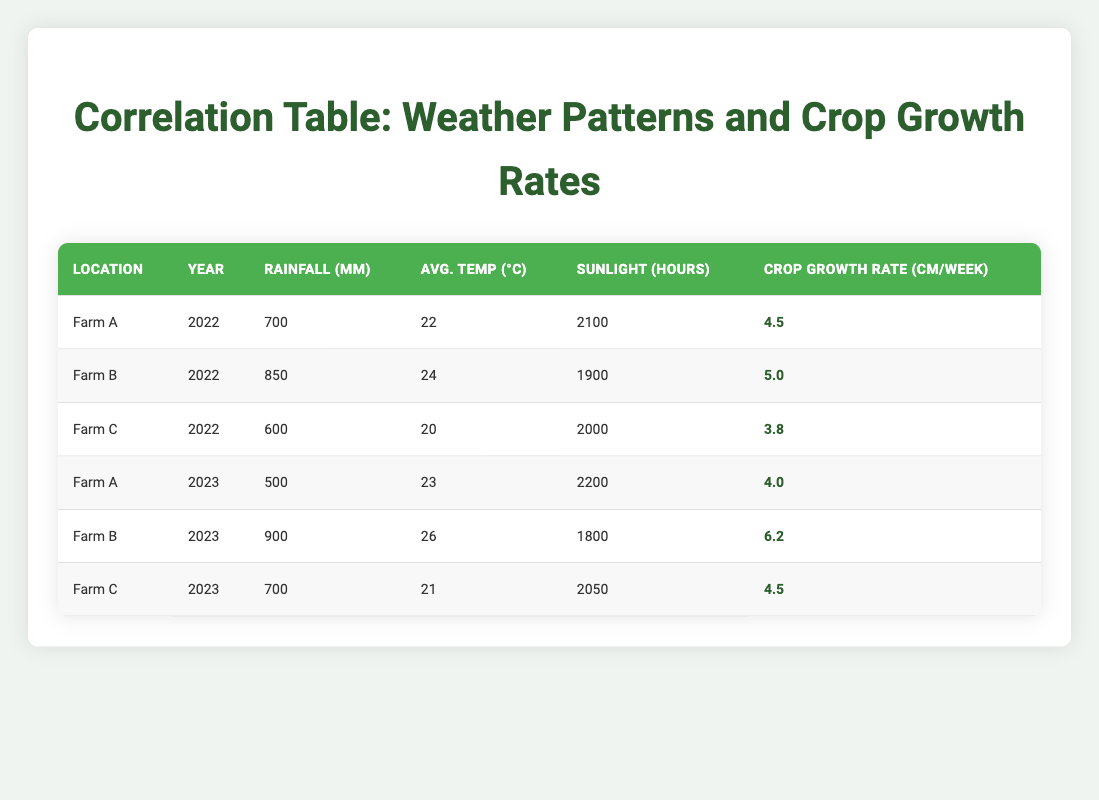What is the average rainfall across all farms in the year 2022? For Farm A, the rainfall is 700 mm, for Farm B it is 850 mm, and for Farm C it is 600 mm. To find the average, sum these values: 700 + 850 + 600 = 2150 mm. Then divide by the number of farms, which is 3: 2150 / 3 = 716.67 mm.
Answer: 716.67 mm Which farm had the highest crop growth rate in 2023? In 2023, Farm A has a crop growth rate of 4.0 cm/week, Farm B has 6.2 cm/week, and Farm C has 4.5 cm/week. By comparing these values, Farm B has the highest crop growth rate of 6.2 cm/week.
Answer: Farm B Did Farm C have a higher average temperature in 2022 than in 2023? Farm C's average temperature in 2022 is 20°C, while in 2023 it is 21°C. Therefore, Farm C's average temperature in 2023 is indeed higher than in 2022.
Answer: Yes What was the total amount of sunlight hours for all farms in 2022? The sunlight hours for Farm A in 2022 are 2100 hours, for Farm B it is 1900 hours, and for Farm C it is 2000 hours. Adding these values together: 2100 + 1900 + 2000 = 6000 hours in total.
Answer: 6000 hours Is there a correlation between rainfall and crop growth rate across the data provided? In the data for 2022, higher rainfall (850 mm for Farm B) corresponds to the highest crop growth rate (5.0 cm/week). However, in 2023, lower rainfall (500 mm for Farm A) shows a crop growth rate of 4.0 cm/week. This indicates inconsistent correlation, but generally, higher rainfall tends to support higher growth rates.
Answer: Inconsistent correlation What was the growth rate difference for Farm A between the years 2022 and 2023? Farm A had a crop growth rate of 4.5 cm/week in 2022 and 4.0 cm/week in 2023. To find the difference: 4.5 - 4.0 = 0.5 cm/week, indicating that growth decreased by this amount.
Answer: 0.5 cm/week Which farm received the least rainfall in 2023? In 2023, Farm A received 500 mm, Farm B received 900 mm, and Farm C received 700 mm. The least amount of rainfall is 500 mm, which corresponds to Farm A.
Answer: Farm A What was the average crop growth rate across all farms in 2022? The crop growth rates for 2022 are 4.5 cm/week for Farm A, 5.0 cm/week for Farm B, and 3.8 cm/week for Farm C. First, sum these values: 4.5 + 5.0 + 3.8 = 13.3 cm/week. Then, divide by 3: 13.3 / 3 ≈ 4.43 cm/week.
Answer: 4.43 cm/week 